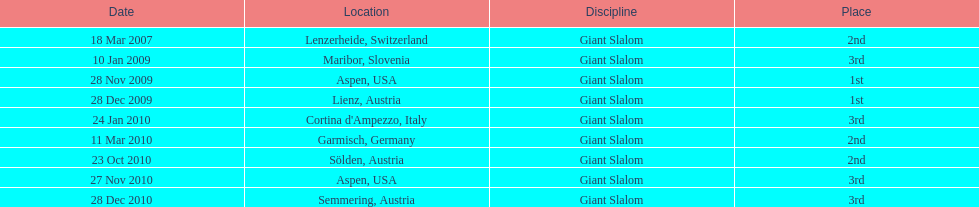The ultimate race conclusion position was not 1st, but which other spot? 3rd. I'm looking to parse the entire table for insights. Could you assist me with that? {'header': ['Date', 'Location', 'Discipline', 'Place'], 'rows': [['18 Mar 2007', 'Lenzerheide, Switzerland', 'Giant Slalom', '2nd'], ['10 Jan 2009', 'Maribor, Slovenia', 'Giant Slalom', '3rd'], ['28 Nov 2009', 'Aspen, USA', 'Giant Slalom', '1st'], ['28 Dec 2009', 'Lienz, Austria', 'Giant Slalom', '1st'], ['24 Jan 2010', "Cortina d'Ampezzo, Italy", 'Giant Slalom', '3rd'], ['11 Mar 2010', 'Garmisch, Germany', 'Giant Slalom', '2nd'], ['23 Oct 2010', 'Sölden, Austria', 'Giant Slalom', '2nd'], ['27 Nov 2010', 'Aspen, USA', 'Giant Slalom', '3rd'], ['28 Dec 2010', 'Semmering, Austria', 'Giant Slalom', '3rd']]} 